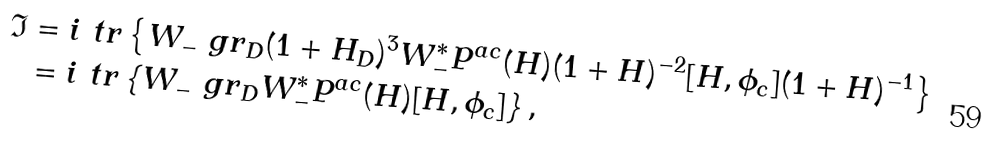<formula> <loc_0><loc_0><loc_500><loc_500>\mathfrak { I } & = i \ t r \left \{ W _ { - } \ g r _ { D } ( 1 + H _ { D } ) ^ { 3 } W _ { - } ^ { * } P ^ { a c } ( H ) ( 1 + H ) ^ { - 2 } [ H , \phi _ { c } ] ( 1 + H ) ^ { - 1 } \right \} \\ & = i \ t r \left \{ W _ { - } \ g r _ { D } W _ { - } ^ { * } P ^ { a c } ( H ) [ H , \phi _ { c } ] \right \} ,</formula> 